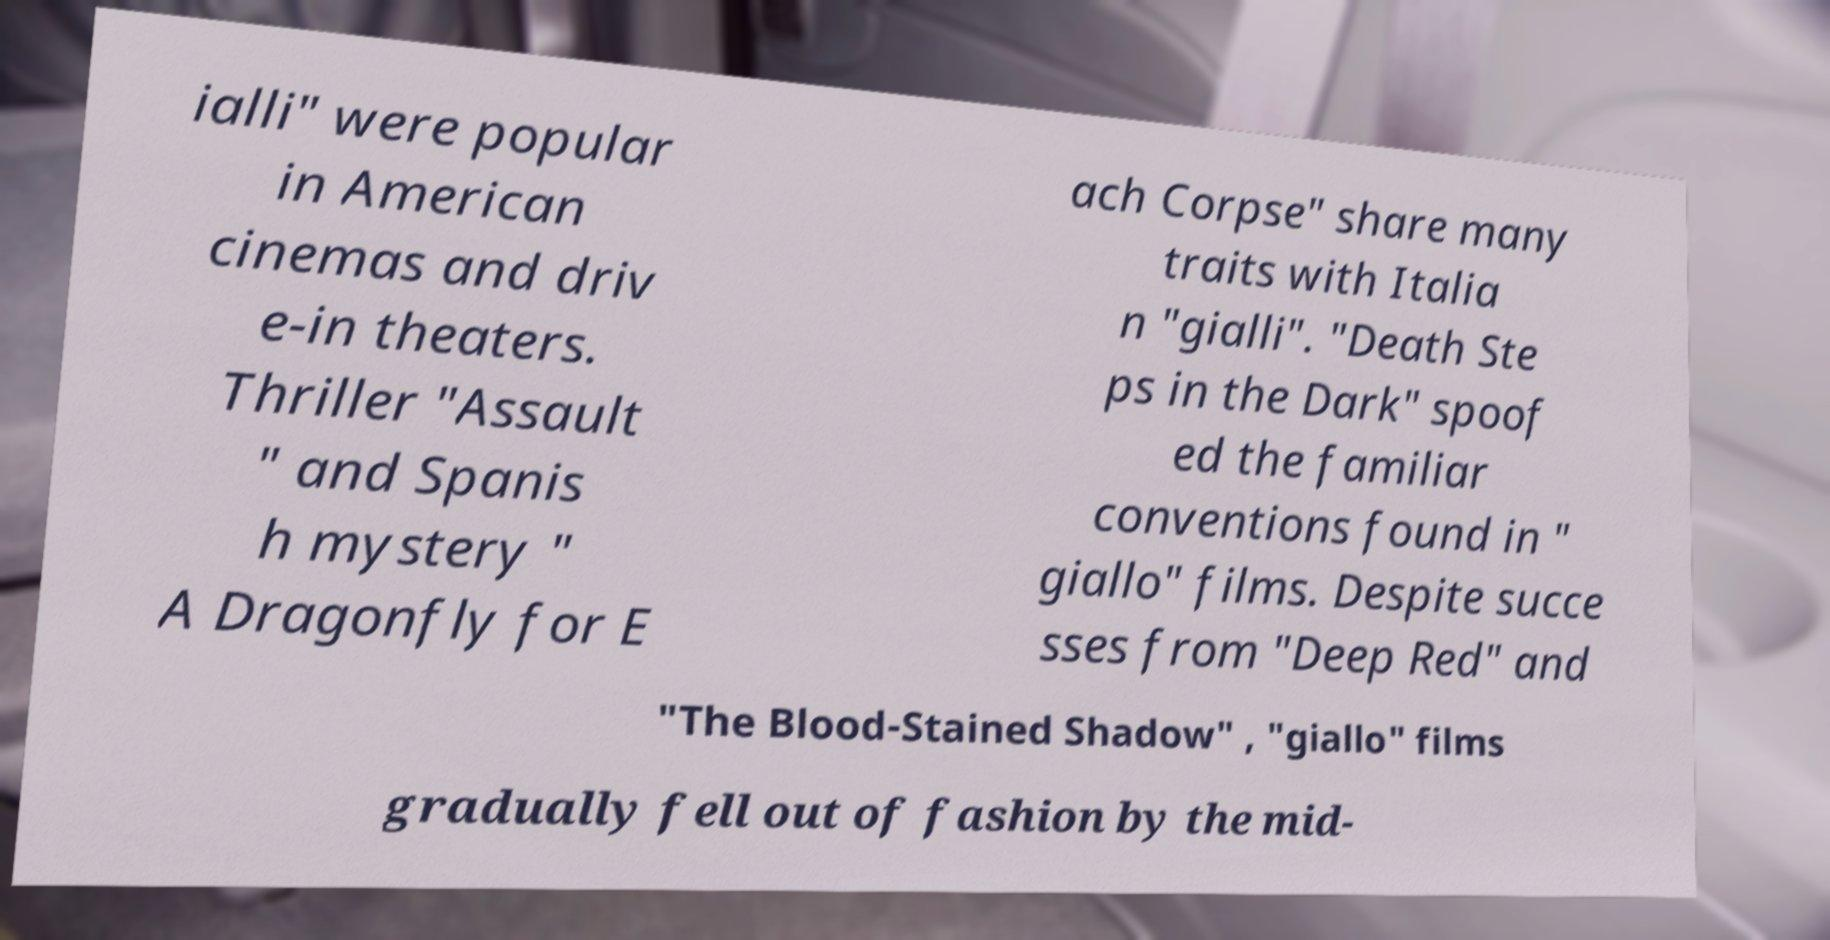What messages or text are displayed in this image? I need them in a readable, typed format. ialli" were popular in American cinemas and driv e-in theaters. Thriller "Assault " and Spanis h mystery " A Dragonfly for E ach Corpse" share many traits with Italia n "gialli". "Death Ste ps in the Dark" spoof ed the familiar conventions found in " giallo" films. Despite succe sses from "Deep Red" and "The Blood-Stained Shadow" , "giallo" films gradually fell out of fashion by the mid- 